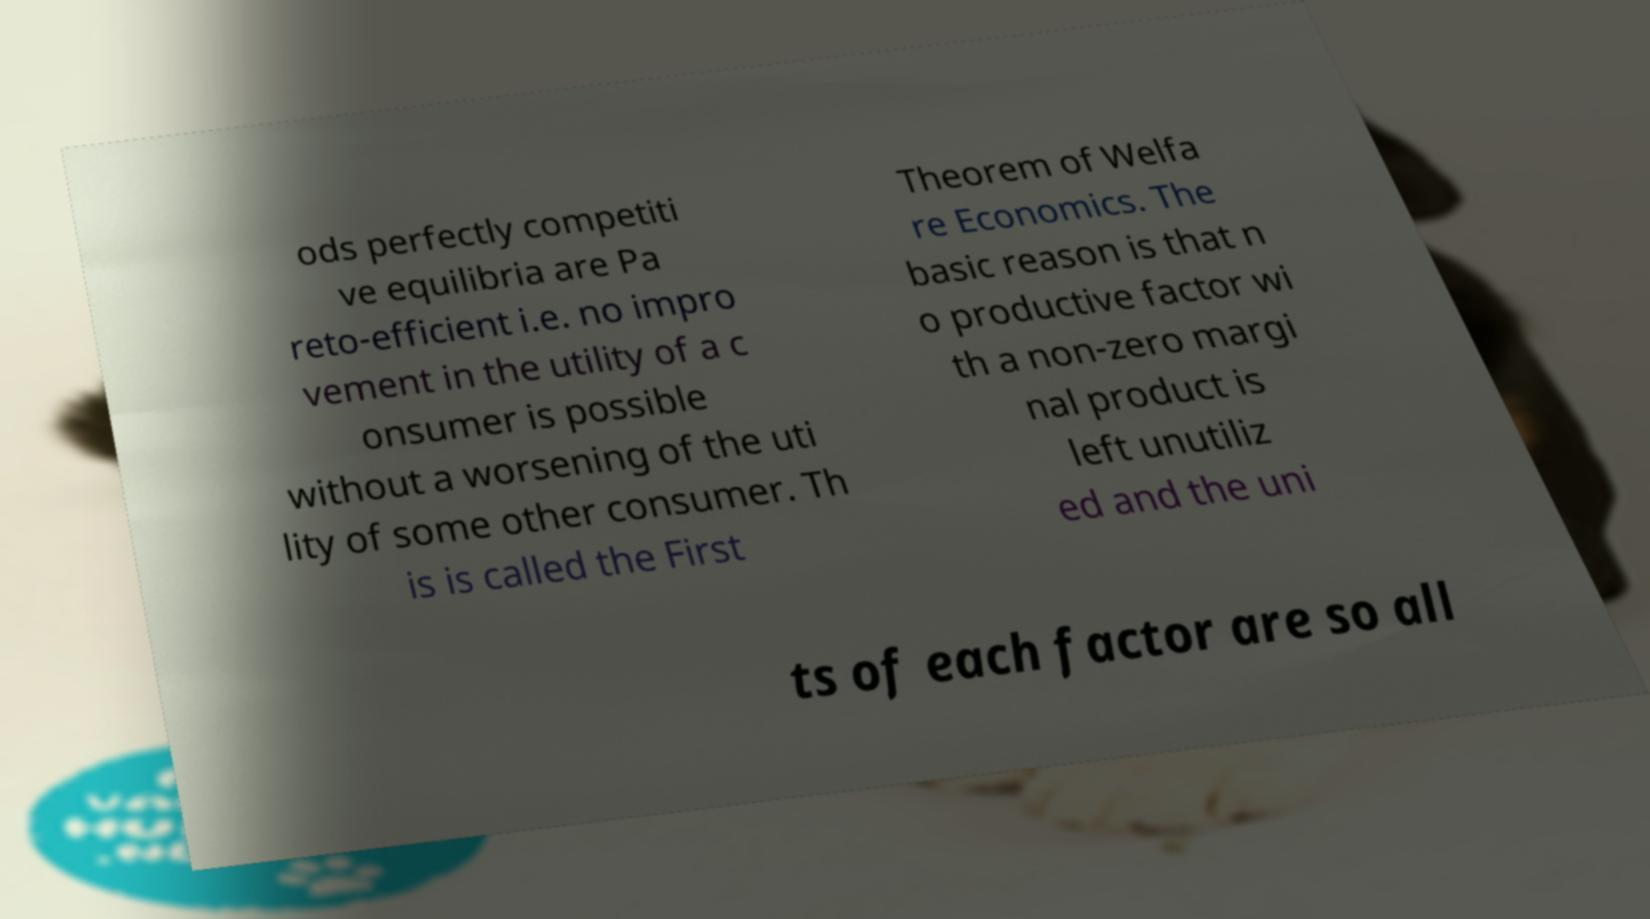Could you extract and type out the text from this image? ods perfectly competiti ve equilibria are Pa reto-efficient i.e. no impro vement in the utility of a c onsumer is possible without a worsening of the uti lity of some other consumer. Th is is called the First Theorem of Welfa re Economics. The basic reason is that n o productive factor wi th a non-zero margi nal product is left unutiliz ed and the uni ts of each factor are so all 